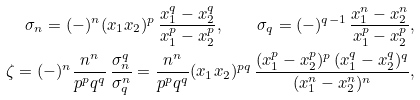<formula> <loc_0><loc_0><loc_500><loc_500>\sigma _ { n } = ( - ) ^ { n } ( x _ { 1 } x _ { 2 } ) ^ { p } \, \frac { x _ { 1 } ^ { q } - x _ { 2 } ^ { q } } { x _ { 1 } ^ { p } - x _ { 2 } ^ { p } } , \quad \sigma _ { q } = ( - ) ^ { q - 1 } \, \frac { x _ { 1 } ^ { n } - x _ { 2 } ^ { n } } { x _ { 1 } ^ { p } - x _ { 2 } ^ { p } } , \\ \zeta = ( - ) ^ { n } \frac { n ^ { n } } { p ^ { p } q ^ { q } } \, \frac { \sigma _ { n } ^ { q } } { \sigma _ { q } ^ { n } } = \frac { n ^ { n } } { p ^ { p } q ^ { q } } ( x _ { 1 } x _ { 2 } ) ^ { p q } \, \frac { ( x _ { 1 } ^ { p } - x _ { 2 } ^ { p } ) ^ { p } \, ( x _ { 1 } ^ { q } - x _ { 2 } ^ { q } ) ^ { q } } { ( x _ { 1 } ^ { n } - x _ { 2 } ^ { n } ) ^ { n } } ,</formula> 